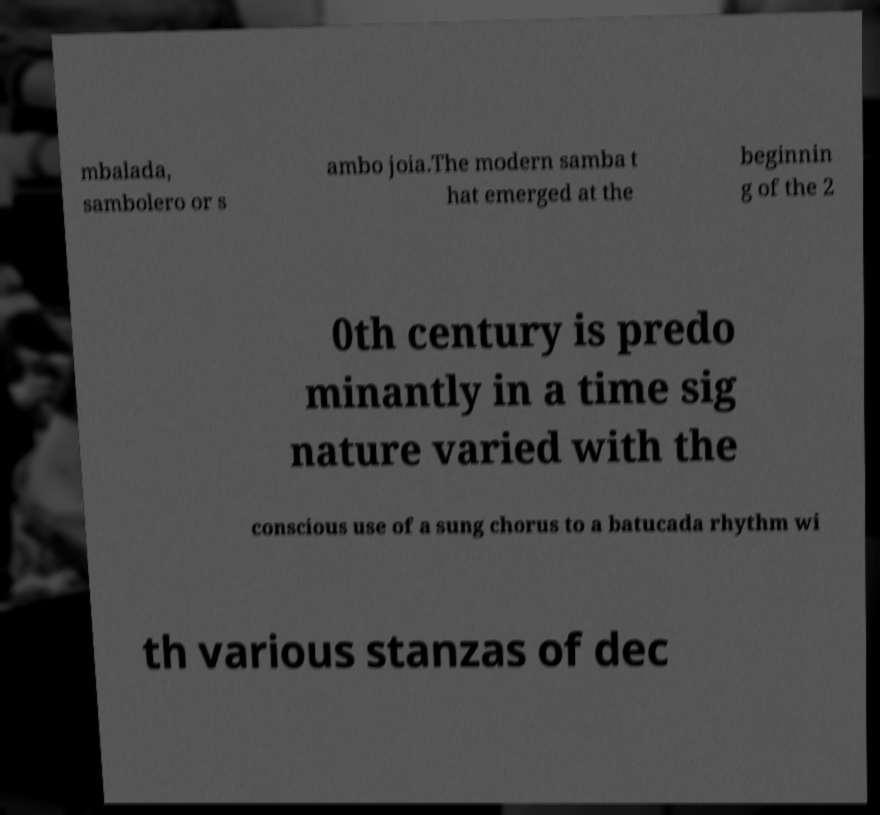Could you assist in decoding the text presented in this image and type it out clearly? mbalada, sambolero or s ambo joia.The modern samba t hat emerged at the beginnin g of the 2 0th century is predo minantly in a time sig nature varied with the conscious use of a sung chorus to a batucada rhythm wi th various stanzas of dec 